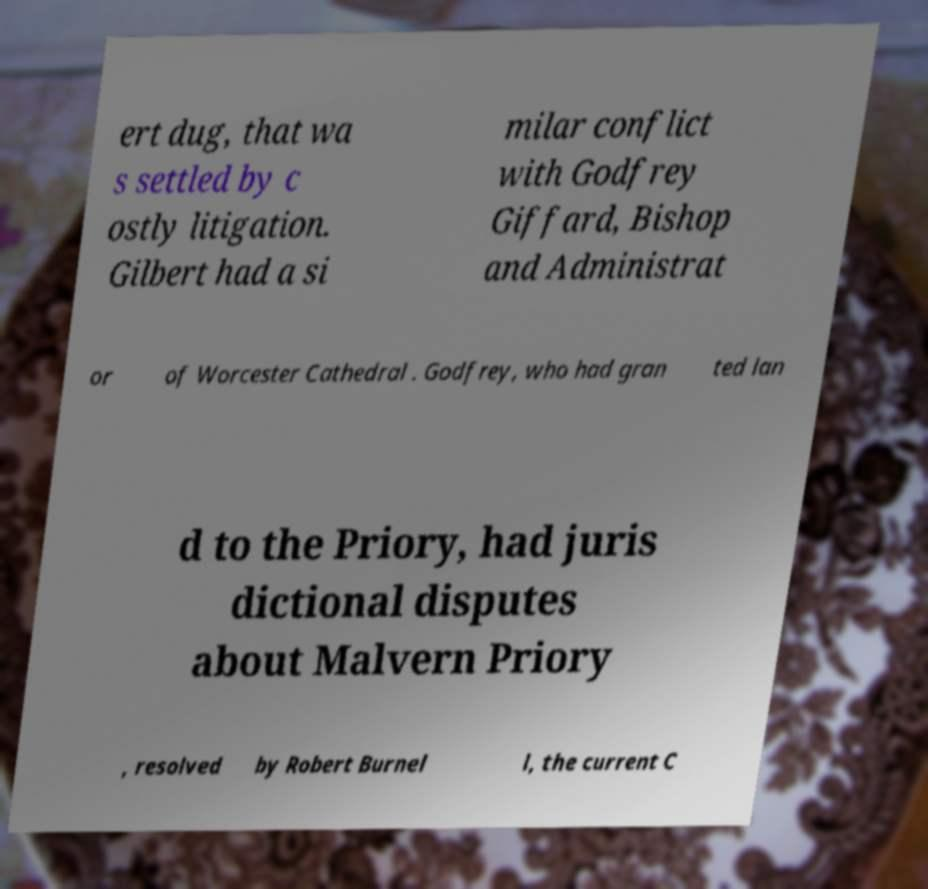Can you read and provide the text displayed in the image?This photo seems to have some interesting text. Can you extract and type it out for me? ert dug, that wa s settled by c ostly litigation. Gilbert had a si milar conflict with Godfrey Giffard, Bishop and Administrat or of Worcester Cathedral . Godfrey, who had gran ted lan d to the Priory, had juris dictional disputes about Malvern Priory , resolved by Robert Burnel l, the current C 